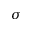Convert formula to latex. <formula><loc_0><loc_0><loc_500><loc_500>\sigma</formula> 